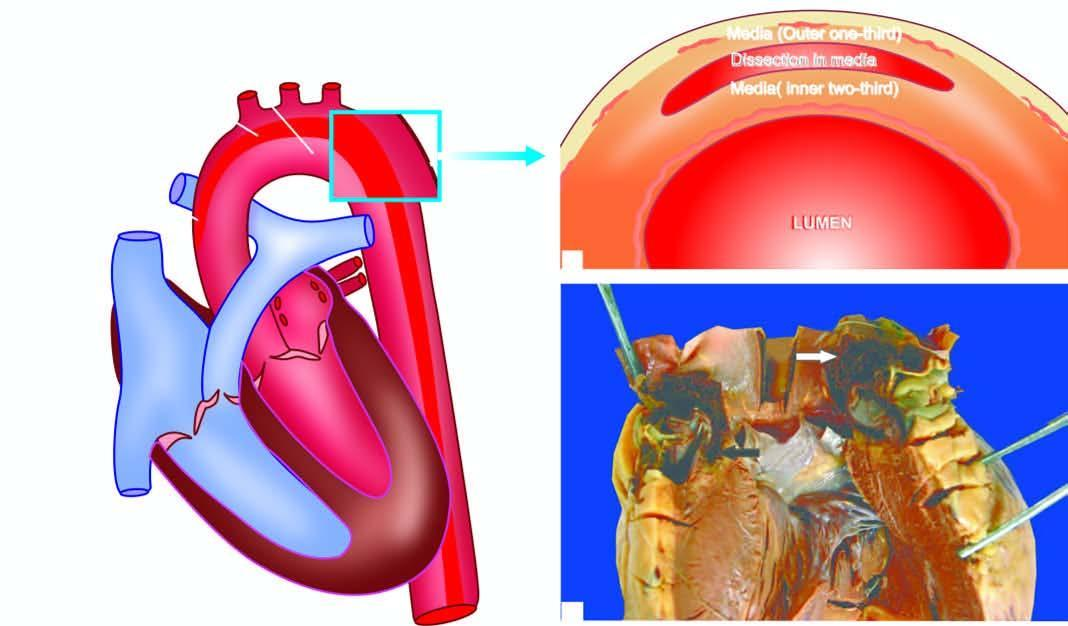does an intimal tear in the aortic wall extend proximally upto aortic valve dissecting the media which contains clotted blood?
Answer the question using a single word or phrase. Yes 